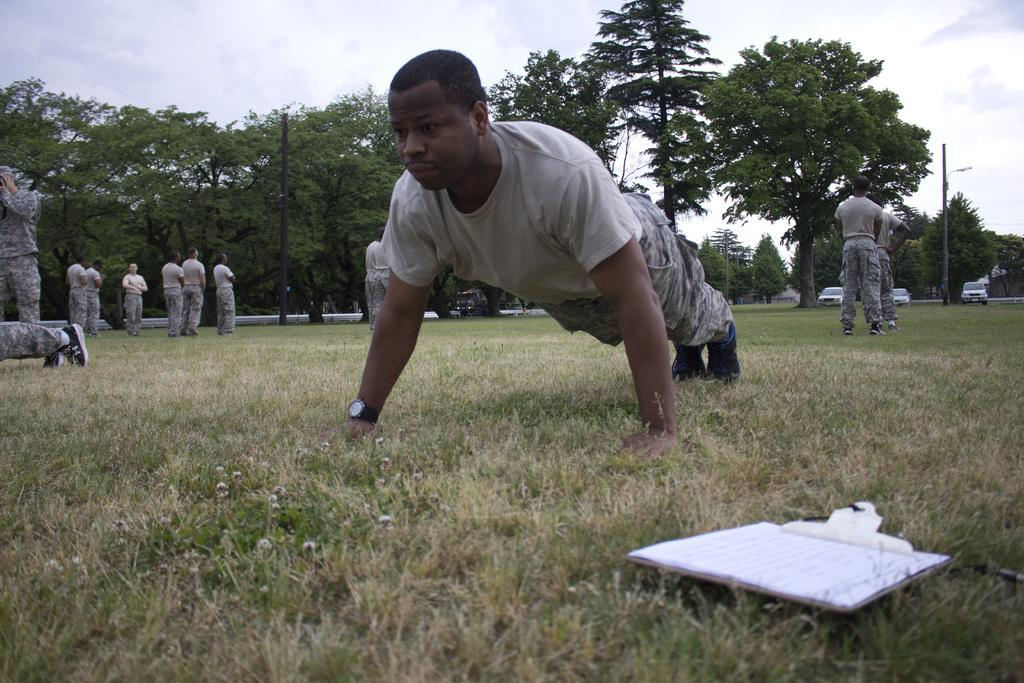What is the person in the image doing? There is a person doing an exercise in the image. Can you describe the surroundings of the person? There are other persons on the ground, trees, poles, vehicles, grass, and the sky is visible in the background. What object related to reading can be seen in the image? There is a book in the image. What type of nail is being used by the person doing the exercise in the image? There is no nail visible in the image, and the person is not using any nail for the exercise. Can you hear the person coughing in the image? The image is silent, and there is no indication of anyone coughing. 